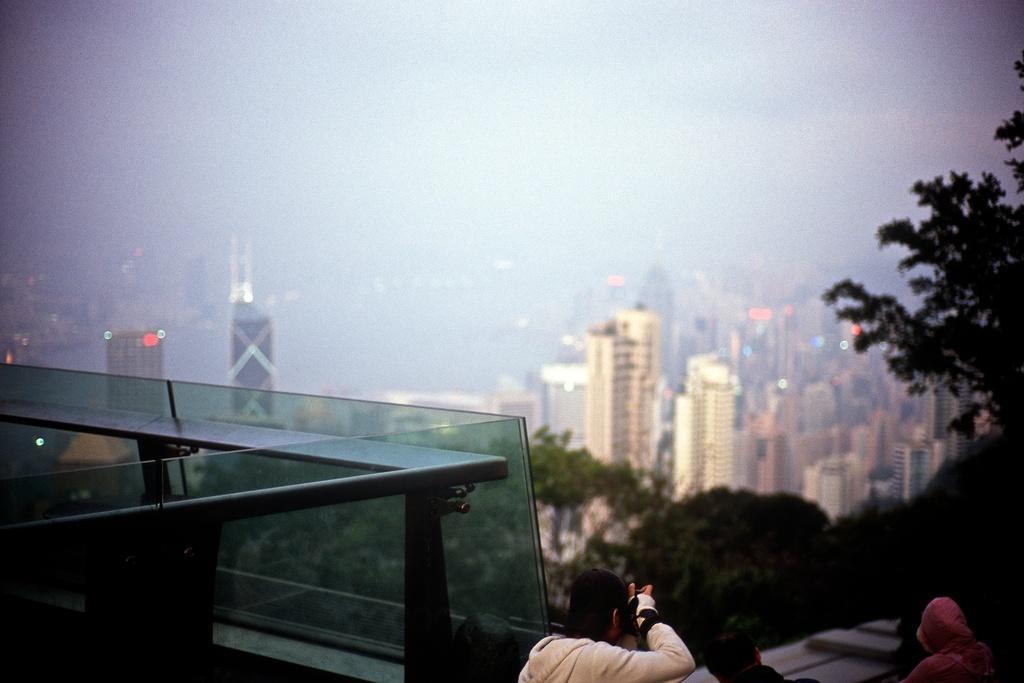Please provide a concise description of this image. In this picture there are people those who are standing at the bottom side of the image and there is a boy at the bottom side of the image, he is taking a photo, there are trees on the right side of the image and there are buildings in the background area of the image. 